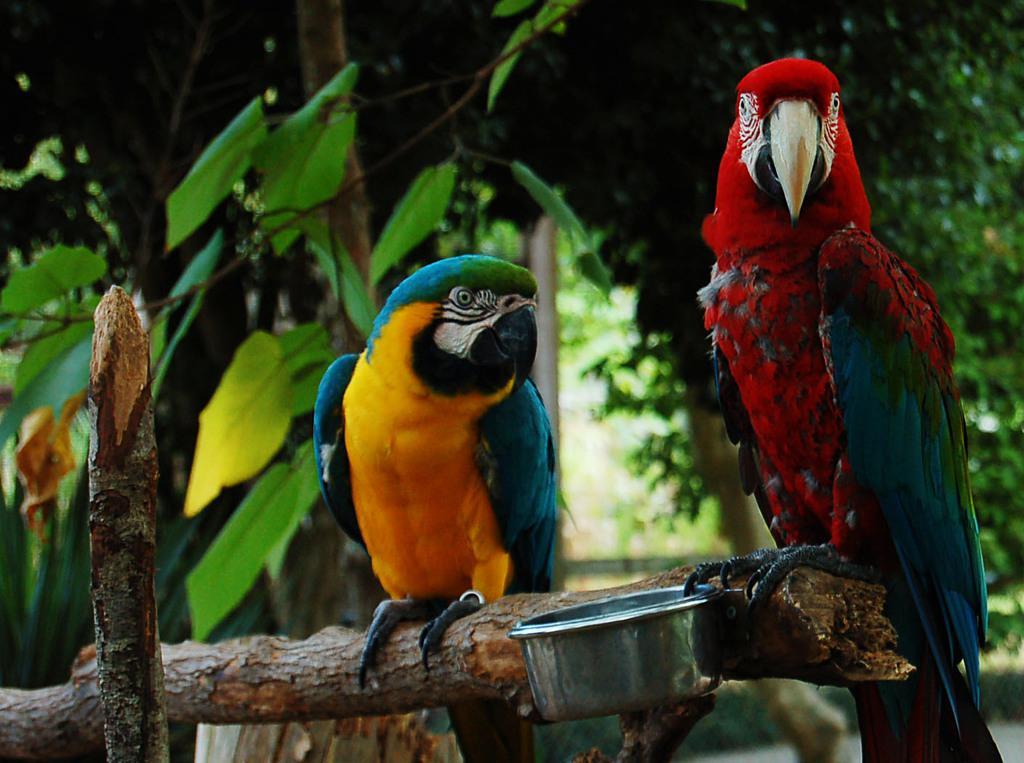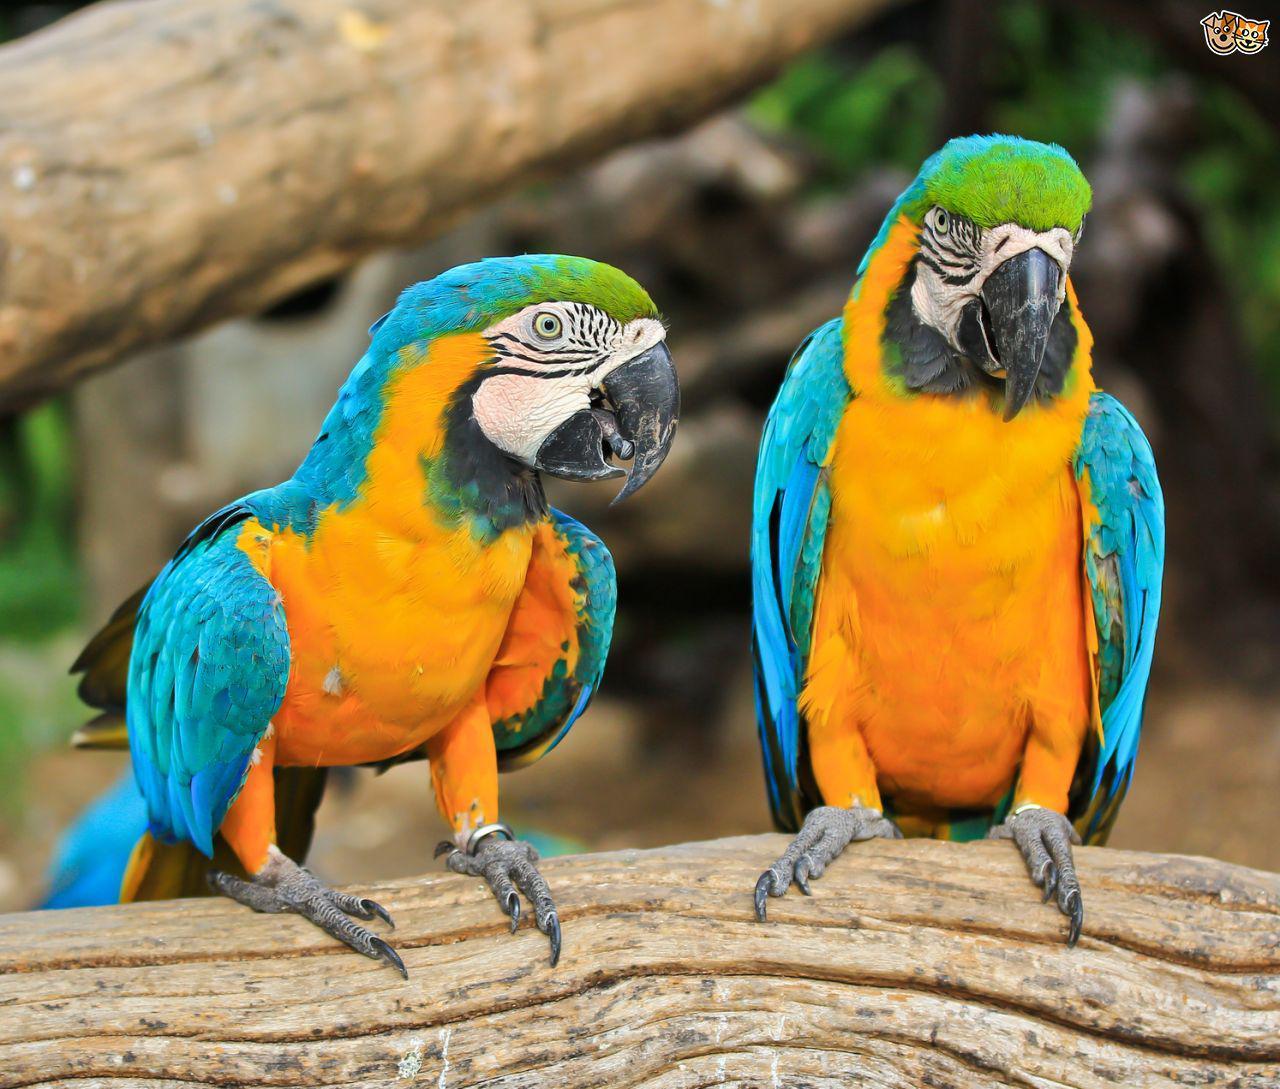The first image is the image on the left, the second image is the image on the right. Given the left and right images, does the statement "There are exactly three parrots in the right image standing on a branch." hold true? Answer yes or no. No. The first image is the image on the left, the second image is the image on the right. Analyze the images presented: Is the assertion "One bird has its wings spread open." valid? Answer yes or no. No. 